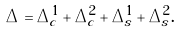Convert formula to latex. <formula><loc_0><loc_0><loc_500><loc_500>\Delta = \Delta ^ { 1 } _ { c } + \Delta ^ { 2 } _ { c } + \Delta ^ { 1 } _ { s } + \Delta ^ { 2 } _ { s } .</formula> 